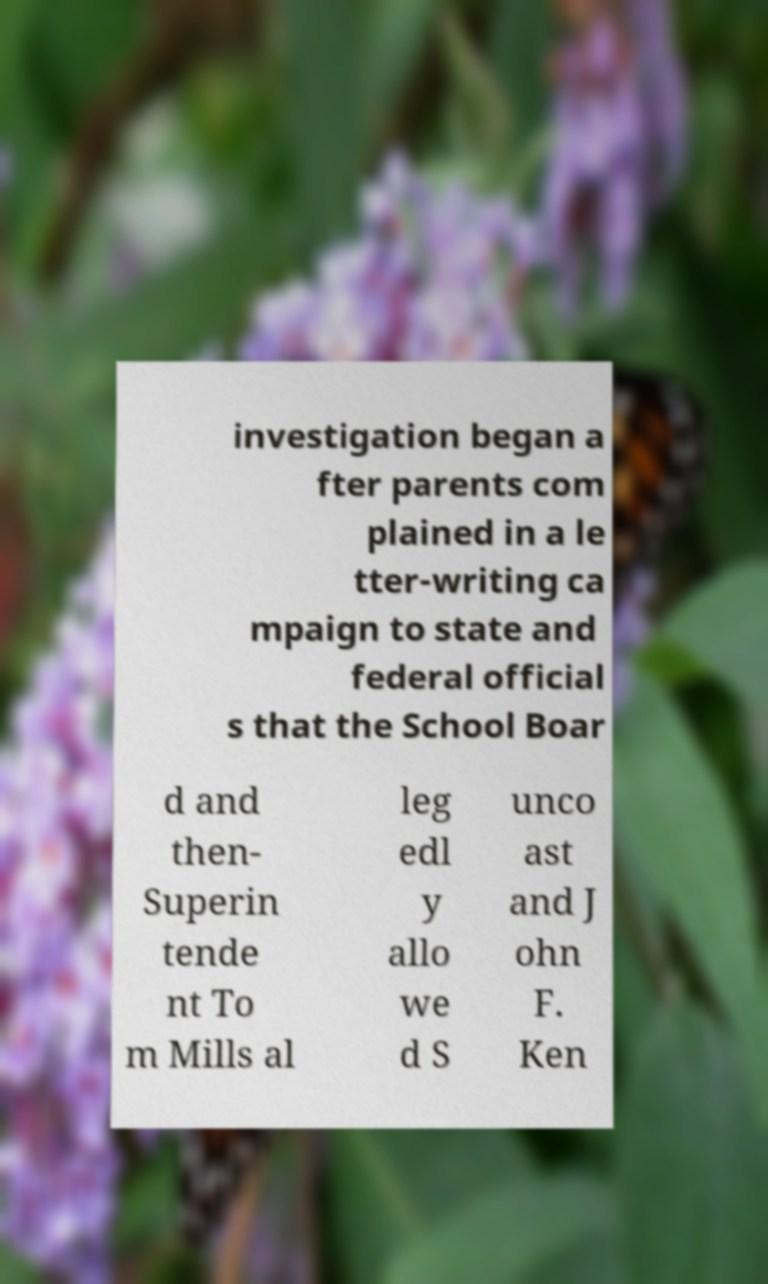Can you read and provide the text displayed in the image?This photo seems to have some interesting text. Can you extract and type it out for me? investigation began a fter parents com plained in a le tter-writing ca mpaign to state and federal official s that the School Boar d and then- Superin tende nt To m Mills al leg edl y allo we d S unco ast and J ohn F. Ken 